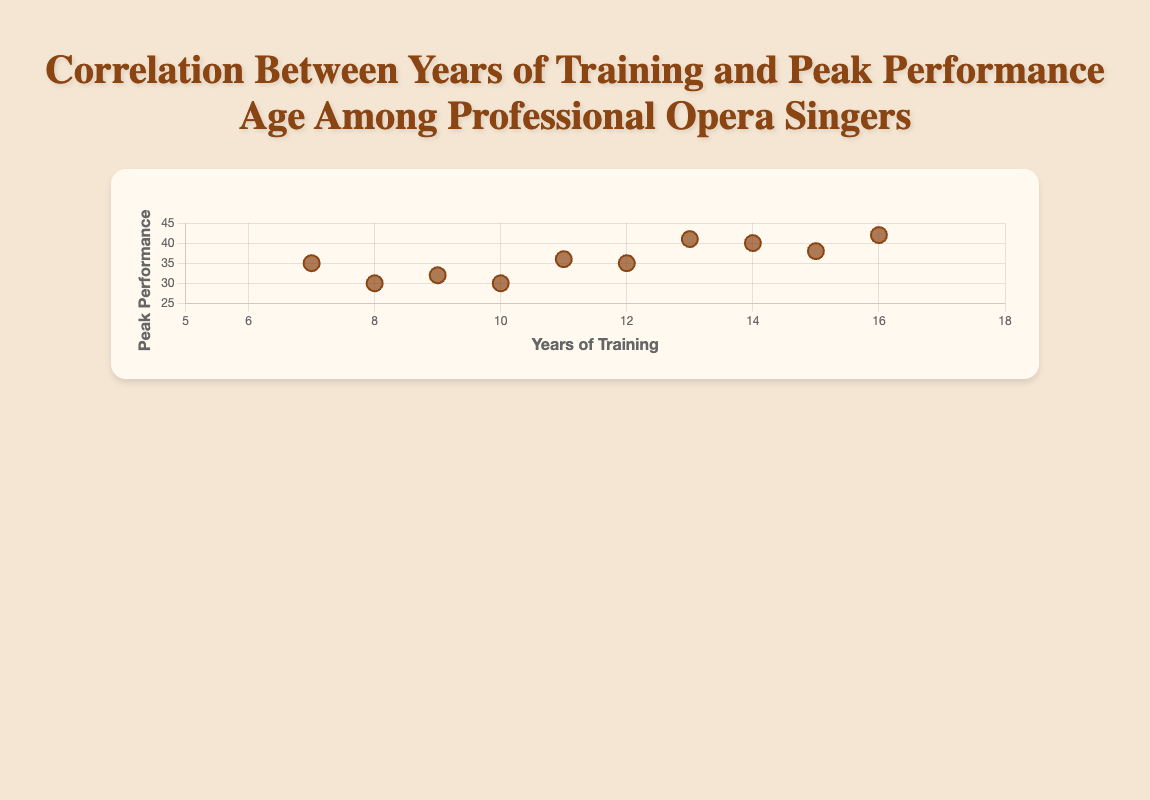How many opera singers are included in the dataset? Count the number of data points on the scatter plot. Each point represents one opera singer.
Answer: 10 Which singer had the longest years of training? Look for the data point with the highest x-axis value, which represents the years of training.
Answer: Montserrat Caballé What is the peak performance age for Renée Fleming? Identify Renée Fleming's data point and check the y-axis value for that point, which represents the peak performance age.
Answer: 36 How many singers peaked at age 35? Count the number of data points that have a y-axis value of 35.
Answer: 2 Who had fewer years of training, Luciano Pavarotti or Joan Sutherland? Compare the x-axis values for Luciano Pavarotti and Joan Sutherland and see which one is lower.
Answer: Luciano Pavarotti What's the difference in peak performance age between Jonas Kaufmann and Maria Callas? Subtract Maria Callas's peak performance age from Jonas Kaufmann's peak performance age (41 - 30).
Answer: 11 Which singer had the least years of training and at what age did they peak? Find the data point with the lowest x-axis value and then note the y-axis value for that point.
Answer: Elīna Garanča, 35 Do more singers have training years between 10 and 15 or outside that range? Count the number of data points where the x-axis value is between 10 and 15, then count those outside this range, and compare the two counts.
Answer: Inside the range (6 vs 4) Which visual element is used to represent the data points? Look at the plotted data and note the shapes used to represent each singer.
Answer: Circles Is there a general trend between years of training and peak performance age? Observe the pattern of data points on the scatter plot to see if there is an upward or downward trend.
Answer: Yes, generally more years of training correlates with higher peak performance ages 